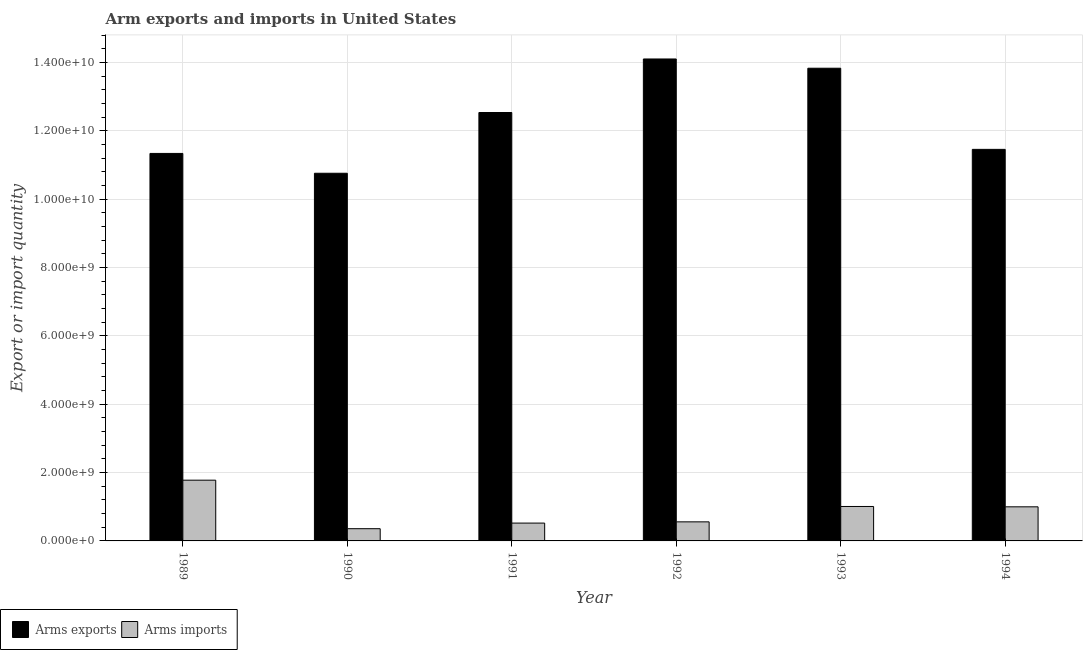How many different coloured bars are there?
Provide a short and direct response. 2. How many bars are there on the 1st tick from the right?
Make the answer very short. 2. What is the label of the 3rd group of bars from the left?
Give a very brief answer. 1991. In how many cases, is the number of bars for a given year not equal to the number of legend labels?
Make the answer very short. 0. What is the arms imports in 1994?
Give a very brief answer. 9.98e+08. Across all years, what is the maximum arms exports?
Your answer should be compact. 1.41e+1. Across all years, what is the minimum arms exports?
Keep it short and to the point. 1.08e+1. In which year was the arms imports maximum?
Keep it short and to the point. 1989. In which year was the arms imports minimum?
Offer a terse response. 1990. What is the total arms imports in the graph?
Make the answer very short. 5.22e+09. What is the difference between the arms imports in 1990 and that in 1992?
Your answer should be very brief. -2.00e+08. What is the difference between the arms exports in 1991 and the arms imports in 1994?
Your answer should be very brief. 1.08e+09. What is the average arms exports per year?
Give a very brief answer. 1.23e+1. In the year 1994, what is the difference between the arms exports and arms imports?
Make the answer very short. 0. What is the ratio of the arms imports in 1991 to that in 1993?
Ensure brevity in your answer.  0.52. Is the difference between the arms imports in 1990 and 1993 greater than the difference between the arms exports in 1990 and 1993?
Keep it short and to the point. No. What is the difference between the highest and the second highest arms exports?
Make the answer very short. 2.71e+08. What is the difference between the highest and the lowest arms exports?
Give a very brief answer. 3.34e+09. In how many years, is the arms imports greater than the average arms imports taken over all years?
Your response must be concise. 3. What does the 1st bar from the left in 1991 represents?
Offer a terse response. Arms exports. What does the 2nd bar from the right in 1993 represents?
Give a very brief answer. Arms exports. How many bars are there?
Keep it short and to the point. 12. Are the values on the major ticks of Y-axis written in scientific E-notation?
Give a very brief answer. Yes. Does the graph contain any zero values?
Keep it short and to the point. No. Where does the legend appear in the graph?
Keep it short and to the point. Bottom left. How many legend labels are there?
Your response must be concise. 2. How are the legend labels stacked?
Offer a terse response. Horizontal. What is the title of the graph?
Your response must be concise. Arm exports and imports in United States. What is the label or title of the Y-axis?
Offer a very short reply. Export or import quantity. What is the Export or import quantity in Arms exports in 1989?
Make the answer very short. 1.13e+1. What is the Export or import quantity in Arms imports in 1989?
Offer a terse response. 1.78e+09. What is the Export or import quantity of Arms exports in 1990?
Your response must be concise. 1.08e+1. What is the Export or import quantity in Arms imports in 1990?
Ensure brevity in your answer.  3.58e+08. What is the Export or import quantity of Arms exports in 1991?
Give a very brief answer. 1.25e+1. What is the Export or import quantity of Arms imports in 1991?
Provide a succinct answer. 5.22e+08. What is the Export or import quantity of Arms exports in 1992?
Your answer should be very brief. 1.41e+1. What is the Export or import quantity in Arms imports in 1992?
Make the answer very short. 5.58e+08. What is the Export or import quantity of Arms exports in 1993?
Your answer should be compact. 1.38e+1. What is the Export or import quantity of Arms imports in 1993?
Provide a short and direct response. 1.01e+09. What is the Export or import quantity of Arms exports in 1994?
Ensure brevity in your answer.  1.15e+1. What is the Export or import quantity of Arms imports in 1994?
Provide a succinct answer. 9.98e+08. Across all years, what is the maximum Export or import quantity in Arms exports?
Your response must be concise. 1.41e+1. Across all years, what is the maximum Export or import quantity of Arms imports?
Your response must be concise. 1.78e+09. Across all years, what is the minimum Export or import quantity in Arms exports?
Your answer should be very brief. 1.08e+1. Across all years, what is the minimum Export or import quantity in Arms imports?
Your answer should be compact. 3.58e+08. What is the total Export or import quantity in Arms exports in the graph?
Make the answer very short. 7.40e+1. What is the total Export or import quantity of Arms imports in the graph?
Offer a very short reply. 5.22e+09. What is the difference between the Export or import quantity of Arms exports in 1989 and that in 1990?
Provide a succinct answer. 5.80e+08. What is the difference between the Export or import quantity in Arms imports in 1989 and that in 1990?
Your response must be concise. 1.42e+09. What is the difference between the Export or import quantity of Arms exports in 1989 and that in 1991?
Your answer should be compact. -1.20e+09. What is the difference between the Export or import quantity of Arms imports in 1989 and that in 1991?
Your answer should be compact. 1.26e+09. What is the difference between the Export or import quantity in Arms exports in 1989 and that in 1992?
Offer a terse response. -2.76e+09. What is the difference between the Export or import quantity in Arms imports in 1989 and that in 1992?
Give a very brief answer. 1.22e+09. What is the difference between the Export or import quantity of Arms exports in 1989 and that in 1993?
Offer a very short reply. -2.49e+09. What is the difference between the Export or import quantity in Arms imports in 1989 and that in 1993?
Your answer should be compact. 7.70e+08. What is the difference between the Export or import quantity in Arms exports in 1989 and that in 1994?
Your response must be concise. -1.19e+08. What is the difference between the Export or import quantity of Arms imports in 1989 and that in 1994?
Offer a very short reply. 7.80e+08. What is the difference between the Export or import quantity of Arms exports in 1990 and that in 1991?
Keep it short and to the point. -1.78e+09. What is the difference between the Export or import quantity in Arms imports in 1990 and that in 1991?
Your response must be concise. -1.64e+08. What is the difference between the Export or import quantity of Arms exports in 1990 and that in 1992?
Your answer should be very brief. -3.34e+09. What is the difference between the Export or import quantity of Arms imports in 1990 and that in 1992?
Ensure brevity in your answer.  -2.00e+08. What is the difference between the Export or import quantity in Arms exports in 1990 and that in 1993?
Your answer should be very brief. -3.07e+09. What is the difference between the Export or import quantity in Arms imports in 1990 and that in 1993?
Your response must be concise. -6.50e+08. What is the difference between the Export or import quantity in Arms exports in 1990 and that in 1994?
Provide a succinct answer. -6.99e+08. What is the difference between the Export or import quantity in Arms imports in 1990 and that in 1994?
Offer a terse response. -6.40e+08. What is the difference between the Export or import quantity in Arms exports in 1991 and that in 1992?
Make the answer very short. -1.57e+09. What is the difference between the Export or import quantity of Arms imports in 1991 and that in 1992?
Give a very brief answer. -3.60e+07. What is the difference between the Export or import quantity in Arms exports in 1991 and that in 1993?
Your response must be concise. -1.30e+09. What is the difference between the Export or import quantity in Arms imports in 1991 and that in 1993?
Provide a short and direct response. -4.86e+08. What is the difference between the Export or import quantity in Arms exports in 1991 and that in 1994?
Provide a succinct answer. 1.08e+09. What is the difference between the Export or import quantity of Arms imports in 1991 and that in 1994?
Keep it short and to the point. -4.76e+08. What is the difference between the Export or import quantity of Arms exports in 1992 and that in 1993?
Your answer should be very brief. 2.71e+08. What is the difference between the Export or import quantity in Arms imports in 1992 and that in 1993?
Keep it short and to the point. -4.50e+08. What is the difference between the Export or import quantity of Arms exports in 1992 and that in 1994?
Ensure brevity in your answer.  2.65e+09. What is the difference between the Export or import quantity in Arms imports in 1992 and that in 1994?
Ensure brevity in your answer.  -4.40e+08. What is the difference between the Export or import quantity in Arms exports in 1993 and that in 1994?
Your response must be concise. 2.38e+09. What is the difference between the Export or import quantity in Arms imports in 1993 and that in 1994?
Your answer should be very brief. 1.00e+07. What is the difference between the Export or import quantity in Arms exports in 1989 and the Export or import quantity in Arms imports in 1990?
Provide a succinct answer. 1.10e+1. What is the difference between the Export or import quantity of Arms exports in 1989 and the Export or import quantity of Arms imports in 1991?
Give a very brief answer. 1.08e+1. What is the difference between the Export or import quantity in Arms exports in 1989 and the Export or import quantity in Arms imports in 1992?
Provide a short and direct response. 1.08e+1. What is the difference between the Export or import quantity of Arms exports in 1989 and the Export or import quantity of Arms imports in 1993?
Keep it short and to the point. 1.03e+1. What is the difference between the Export or import quantity in Arms exports in 1989 and the Export or import quantity in Arms imports in 1994?
Make the answer very short. 1.03e+1. What is the difference between the Export or import quantity of Arms exports in 1990 and the Export or import quantity of Arms imports in 1991?
Offer a terse response. 1.02e+1. What is the difference between the Export or import quantity in Arms exports in 1990 and the Export or import quantity in Arms imports in 1992?
Ensure brevity in your answer.  1.02e+1. What is the difference between the Export or import quantity of Arms exports in 1990 and the Export or import quantity of Arms imports in 1993?
Provide a short and direct response. 9.75e+09. What is the difference between the Export or import quantity in Arms exports in 1990 and the Export or import quantity in Arms imports in 1994?
Your answer should be very brief. 9.76e+09. What is the difference between the Export or import quantity of Arms exports in 1991 and the Export or import quantity of Arms imports in 1992?
Offer a terse response. 1.20e+1. What is the difference between the Export or import quantity of Arms exports in 1991 and the Export or import quantity of Arms imports in 1993?
Your response must be concise. 1.15e+1. What is the difference between the Export or import quantity of Arms exports in 1991 and the Export or import quantity of Arms imports in 1994?
Give a very brief answer. 1.15e+1. What is the difference between the Export or import quantity in Arms exports in 1992 and the Export or import quantity in Arms imports in 1993?
Make the answer very short. 1.31e+1. What is the difference between the Export or import quantity in Arms exports in 1992 and the Export or import quantity in Arms imports in 1994?
Your response must be concise. 1.31e+1. What is the difference between the Export or import quantity in Arms exports in 1993 and the Export or import quantity in Arms imports in 1994?
Make the answer very short. 1.28e+1. What is the average Export or import quantity of Arms exports per year?
Provide a succinct answer. 1.23e+1. What is the average Export or import quantity in Arms imports per year?
Keep it short and to the point. 8.70e+08. In the year 1989, what is the difference between the Export or import quantity of Arms exports and Export or import quantity of Arms imports?
Your response must be concise. 9.56e+09. In the year 1990, what is the difference between the Export or import quantity in Arms exports and Export or import quantity in Arms imports?
Offer a terse response. 1.04e+1. In the year 1991, what is the difference between the Export or import quantity of Arms exports and Export or import quantity of Arms imports?
Offer a terse response. 1.20e+1. In the year 1992, what is the difference between the Export or import quantity in Arms exports and Export or import quantity in Arms imports?
Your response must be concise. 1.35e+1. In the year 1993, what is the difference between the Export or import quantity of Arms exports and Export or import quantity of Arms imports?
Your response must be concise. 1.28e+1. In the year 1994, what is the difference between the Export or import quantity in Arms exports and Export or import quantity in Arms imports?
Your answer should be very brief. 1.05e+1. What is the ratio of the Export or import quantity of Arms exports in 1989 to that in 1990?
Your response must be concise. 1.05. What is the ratio of the Export or import quantity of Arms imports in 1989 to that in 1990?
Your answer should be compact. 4.97. What is the ratio of the Export or import quantity in Arms exports in 1989 to that in 1991?
Your answer should be very brief. 0.9. What is the ratio of the Export or import quantity of Arms imports in 1989 to that in 1991?
Your answer should be compact. 3.41. What is the ratio of the Export or import quantity in Arms exports in 1989 to that in 1992?
Offer a very short reply. 0.8. What is the ratio of the Export or import quantity in Arms imports in 1989 to that in 1992?
Offer a very short reply. 3.19. What is the ratio of the Export or import quantity in Arms exports in 1989 to that in 1993?
Your response must be concise. 0.82. What is the ratio of the Export or import quantity of Arms imports in 1989 to that in 1993?
Make the answer very short. 1.76. What is the ratio of the Export or import quantity in Arms exports in 1989 to that in 1994?
Your answer should be compact. 0.99. What is the ratio of the Export or import quantity of Arms imports in 1989 to that in 1994?
Provide a short and direct response. 1.78. What is the ratio of the Export or import quantity of Arms exports in 1990 to that in 1991?
Offer a very short reply. 0.86. What is the ratio of the Export or import quantity of Arms imports in 1990 to that in 1991?
Ensure brevity in your answer.  0.69. What is the ratio of the Export or import quantity in Arms exports in 1990 to that in 1992?
Offer a terse response. 0.76. What is the ratio of the Export or import quantity of Arms imports in 1990 to that in 1992?
Offer a terse response. 0.64. What is the ratio of the Export or import quantity of Arms exports in 1990 to that in 1993?
Your response must be concise. 0.78. What is the ratio of the Export or import quantity of Arms imports in 1990 to that in 1993?
Provide a succinct answer. 0.36. What is the ratio of the Export or import quantity in Arms exports in 1990 to that in 1994?
Keep it short and to the point. 0.94. What is the ratio of the Export or import quantity of Arms imports in 1990 to that in 1994?
Provide a succinct answer. 0.36. What is the ratio of the Export or import quantity of Arms imports in 1991 to that in 1992?
Provide a succinct answer. 0.94. What is the ratio of the Export or import quantity in Arms exports in 1991 to that in 1993?
Provide a short and direct response. 0.91. What is the ratio of the Export or import quantity in Arms imports in 1991 to that in 1993?
Give a very brief answer. 0.52. What is the ratio of the Export or import quantity of Arms exports in 1991 to that in 1994?
Keep it short and to the point. 1.09. What is the ratio of the Export or import quantity of Arms imports in 1991 to that in 1994?
Offer a very short reply. 0.52. What is the ratio of the Export or import quantity of Arms exports in 1992 to that in 1993?
Your response must be concise. 1.02. What is the ratio of the Export or import quantity in Arms imports in 1992 to that in 1993?
Your answer should be very brief. 0.55. What is the ratio of the Export or import quantity in Arms exports in 1992 to that in 1994?
Ensure brevity in your answer.  1.23. What is the ratio of the Export or import quantity of Arms imports in 1992 to that in 1994?
Your response must be concise. 0.56. What is the ratio of the Export or import quantity of Arms exports in 1993 to that in 1994?
Provide a succinct answer. 1.21. What is the ratio of the Export or import quantity in Arms imports in 1993 to that in 1994?
Your response must be concise. 1.01. What is the difference between the highest and the second highest Export or import quantity in Arms exports?
Your answer should be very brief. 2.71e+08. What is the difference between the highest and the second highest Export or import quantity in Arms imports?
Your answer should be compact. 7.70e+08. What is the difference between the highest and the lowest Export or import quantity of Arms exports?
Give a very brief answer. 3.34e+09. What is the difference between the highest and the lowest Export or import quantity of Arms imports?
Your answer should be very brief. 1.42e+09. 